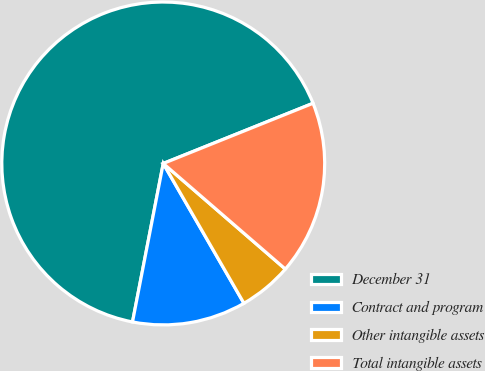Convert chart. <chart><loc_0><loc_0><loc_500><loc_500><pie_chart><fcel>December 31<fcel>Contract and program<fcel>Other intangible assets<fcel>Total intangible assets<nl><fcel>65.87%<fcel>11.38%<fcel>5.32%<fcel>17.43%<nl></chart> 